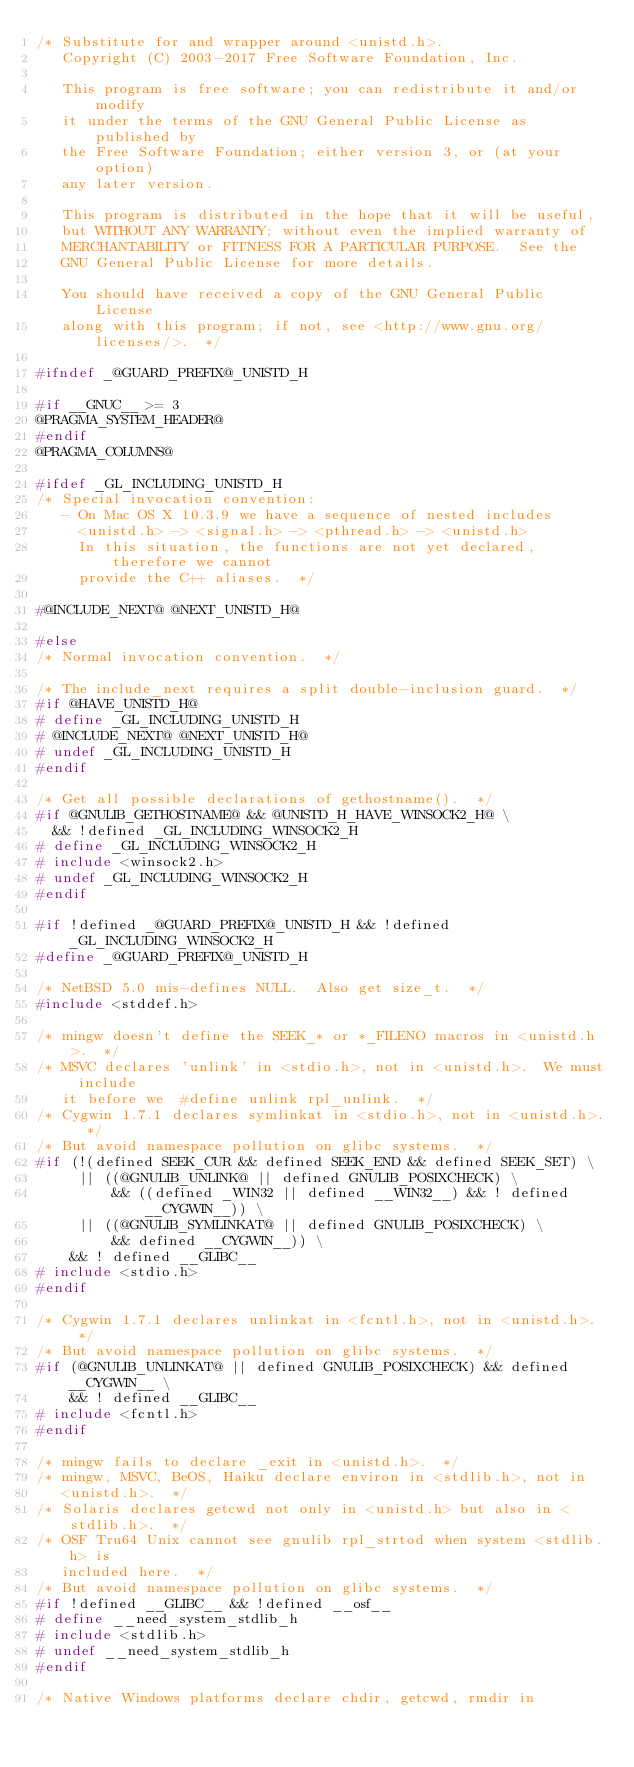<code> <loc_0><loc_0><loc_500><loc_500><_C_>/* Substitute for and wrapper around <unistd.h>.
   Copyright (C) 2003-2017 Free Software Foundation, Inc.

   This program is free software; you can redistribute it and/or modify
   it under the terms of the GNU General Public License as published by
   the Free Software Foundation; either version 3, or (at your option)
   any later version.

   This program is distributed in the hope that it will be useful,
   but WITHOUT ANY WARRANTY; without even the implied warranty of
   MERCHANTABILITY or FITNESS FOR A PARTICULAR PURPOSE.  See the
   GNU General Public License for more details.

   You should have received a copy of the GNU General Public License
   along with this program; if not, see <http://www.gnu.org/licenses/>.  */

#ifndef _@GUARD_PREFIX@_UNISTD_H

#if __GNUC__ >= 3
@PRAGMA_SYSTEM_HEADER@
#endif
@PRAGMA_COLUMNS@

#ifdef _GL_INCLUDING_UNISTD_H
/* Special invocation convention:
   - On Mac OS X 10.3.9 we have a sequence of nested includes
     <unistd.h> -> <signal.h> -> <pthread.h> -> <unistd.h>
     In this situation, the functions are not yet declared, therefore we cannot
     provide the C++ aliases.  */

#@INCLUDE_NEXT@ @NEXT_UNISTD_H@

#else
/* Normal invocation convention.  */

/* The include_next requires a split double-inclusion guard.  */
#if @HAVE_UNISTD_H@
# define _GL_INCLUDING_UNISTD_H
# @INCLUDE_NEXT@ @NEXT_UNISTD_H@
# undef _GL_INCLUDING_UNISTD_H
#endif

/* Get all possible declarations of gethostname().  */
#if @GNULIB_GETHOSTNAME@ && @UNISTD_H_HAVE_WINSOCK2_H@ \
  && !defined _GL_INCLUDING_WINSOCK2_H
# define _GL_INCLUDING_WINSOCK2_H
# include <winsock2.h>
# undef _GL_INCLUDING_WINSOCK2_H
#endif

#if !defined _@GUARD_PREFIX@_UNISTD_H && !defined _GL_INCLUDING_WINSOCK2_H
#define _@GUARD_PREFIX@_UNISTD_H

/* NetBSD 5.0 mis-defines NULL.  Also get size_t.  */
#include <stddef.h>

/* mingw doesn't define the SEEK_* or *_FILENO macros in <unistd.h>.  */
/* MSVC declares 'unlink' in <stdio.h>, not in <unistd.h>.  We must include
   it before we  #define unlink rpl_unlink.  */
/* Cygwin 1.7.1 declares symlinkat in <stdio.h>, not in <unistd.h>.  */
/* But avoid namespace pollution on glibc systems.  */
#if (!(defined SEEK_CUR && defined SEEK_END && defined SEEK_SET) \
     || ((@GNULIB_UNLINK@ || defined GNULIB_POSIXCHECK) \
         && ((defined _WIN32 || defined __WIN32__) && ! defined __CYGWIN__)) \
     || ((@GNULIB_SYMLINKAT@ || defined GNULIB_POSIXCHECK) \
         && defined __CYGWIN__)) \
    && ! defined __GLIBC__
# include <stdio.h>
#endif

/* Cygwin 1.7.1 declares unlinkat in <fcntl.h>, not in <unistd.h>.  */
/* But avoid namespace pollution on glibc systems.  */
#if (@GNULIB_UNLINKAT@ || defined GNULIB_POSIXCHECK) && defined __CYGWIN__ \
    && ! defined __GLIBC__
# include <fcntl.h>
#endif

/* mingw fails to declare _exit in <unistd.h>.  */
/* mingw, MSVC, BeOS, Haiku declare environ in <stdlib.h>, not in
   <unistd.h>.  */
/* Solaris declares getcwd not only in <unistd.h> but also in <stdlib.h>.  */
/* OSF Tru64 Unix cannot see gnulib rpl_strtod when system <stdlib.h> is
   included here.  */
/* But avoid namespace pollution on glibc systems.  */
#if !defined __GLIBC__ && !defined __osf__
# define __need_system_stdlib_h
# include <stdlib.h>
# undef __need_system_stdlib_h
#endif

/* Native Windows platforms declare chdir, getcwd, rmdir in</code> 